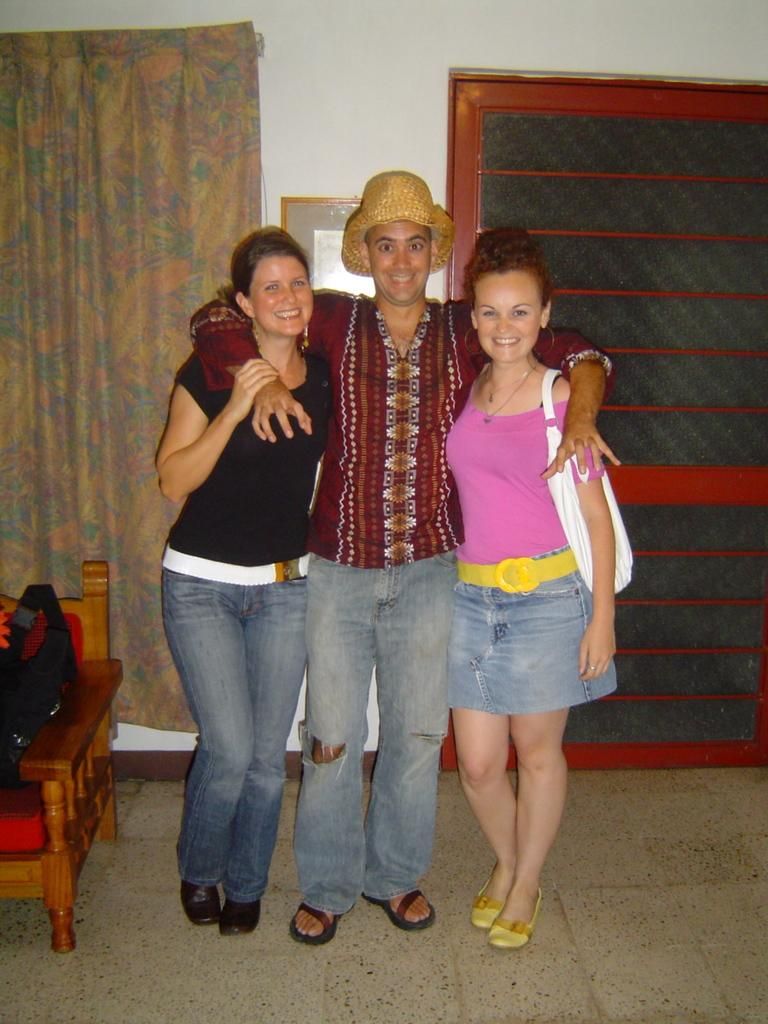How many people are in the image? There are three people in the image: one man and two women. What are the people in the image doing? The man and women are standing on the floor and smiling. What is present in the background of the image? There is a curtain and a frame on the wall in the background of the image. What furniture is visible in the image? There is a chair in the image. What type of rake is being used by the man in the image? There is no rake present in the image; the man is simply standing and smiling. What observation can be made about the women's clothing in the image? There is no specific observation about the women's clothing mentioned in the provided facts, so we cannot answer this question. 